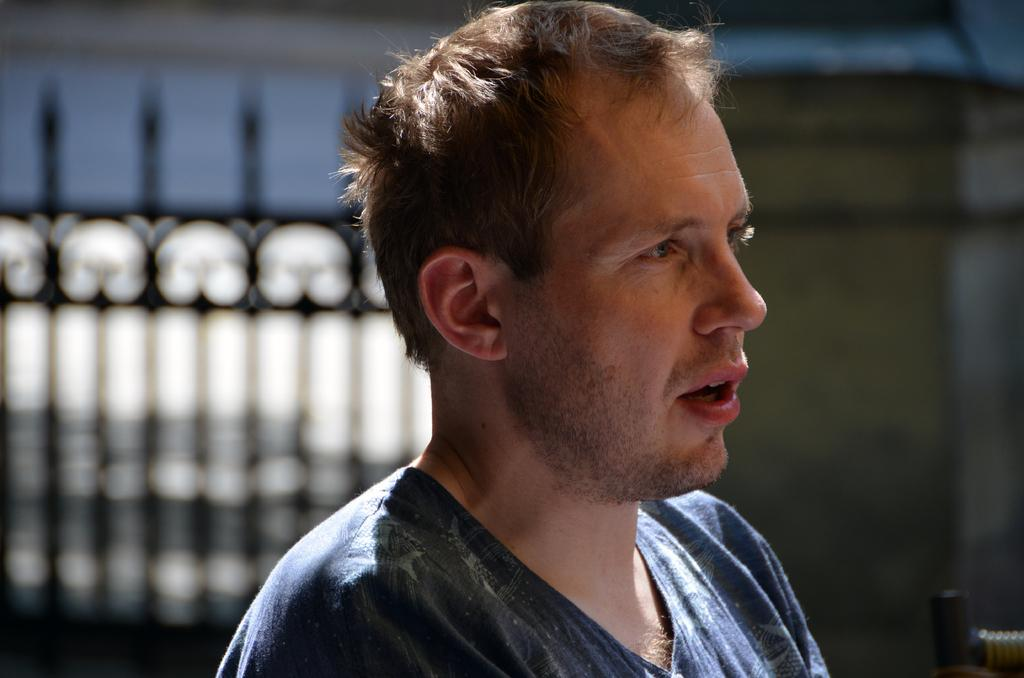What is the person in the image wearing? The person in the image is wearing a blue t-shirt. What can be seen in the background of the image? There is a railing and a wall in the background of the image. Can you hear the person whistling in the image? There is no indication of whistling or any sound in the image, as it is a still photograph. 